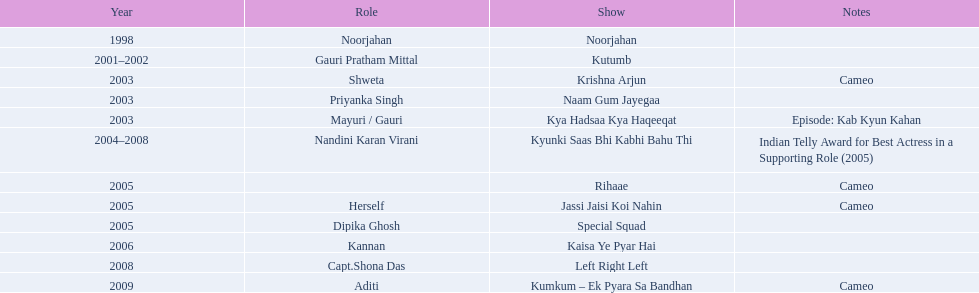What is the longest duration for which a show has lasted? 4. 